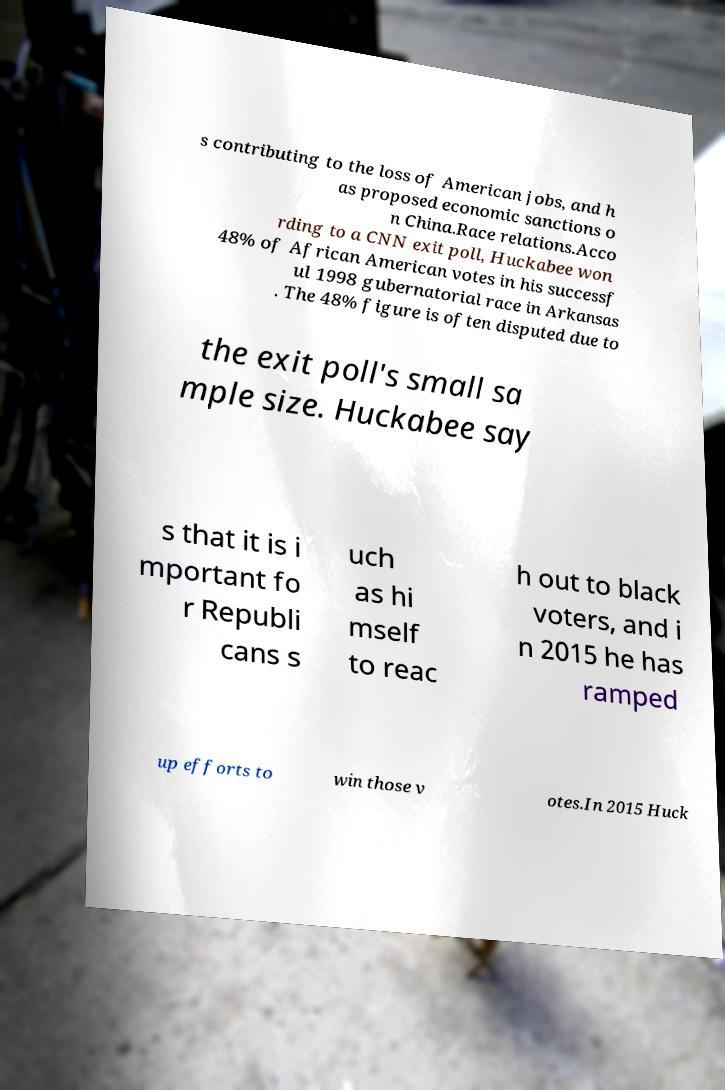Can you read and provide the text displayed in the image?This photo seems to have some interesting text. Can you extract and type it out for me? s contributing to the loss of American jobs, and h as proposed economic sanctions o n China.Race relations.Acco rding to a CNN exit poll, Huckabee won 48% of African American votes in his successf ul 1998 gubernatorial race in Arkansas . The 48% figure is often disputed due to the exit poll's small sa mple size. Huckabee say s that it is i mportant fo r Republi cans s uch as hi mself to reac h out to black voters, and i n 2015 he has ramped up efforts to win those v otes.In 2015 Huck 